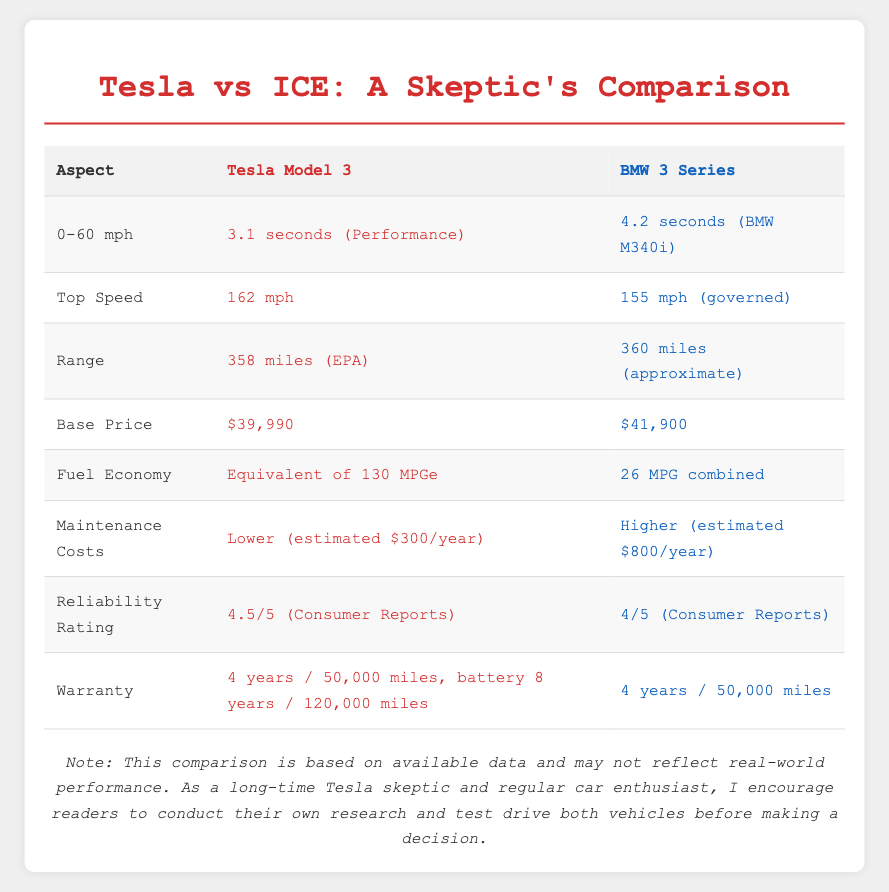What is the 0-60 mph time for the Tesla Model 3? The Tesla Model 3 has a 0-60 mph time of 3.1 seconds (Performance) as stated in the document.
Answer: 3.1 seconds (Performance) What is the base price of the BMW 3 Series? The base price for the BMW 3 Series is mentioned in the document as $41,900.
Answer: $41,900 How long is the warranty coverage for the battery in the Tesla Model 3? The document specifies that the battery warranty for the Tesla Model 3 is 8 years / 120,000 miles.
Answer: 8 years / 120,000 miles Which vehicle has a higher fuel economy? Comparing the fuel economies listed, the Tesla Model 3 has an equivalent of 130 MPGe, while the BMW 3 Series has 26 MPG combined.
Answer: Tesla Model 3 What is the estimated annual maintenance cost for the BMW 3 Series? The document notes that the estimated maintenance cost for the BMW 3 Series is higher at $800/year.
Answer: $800/year How does the reliability rating of the Tesla Model 3 compare to that of the BMW 3 Series? The Tesla Model 3 has a reliability rating of 4.5/5 and the BMW 3 Series has a rating of 4/5 as per the document.
Answer: Tesla Model 3 is higher What is the top speed of the BMW 3 Series? The document indicates that the top speed of the BMW 3 Series is 155 mph (governed).
Answer: 155 mph (governed) Which vehicle has a longer range? Both vehicles have similar range figures, but the Tesla Model 3 lists 358 miles (EPA) while the BMW 3 Series is approximately 360 miles.
Answer: BMW 3 Series What aspect does this document compare specifically? The document compares Tesla vehicles with traditional internal combustion engine vehicles on aspects like performance, price, and reliability.
Answer: Performance, price, and reliability 